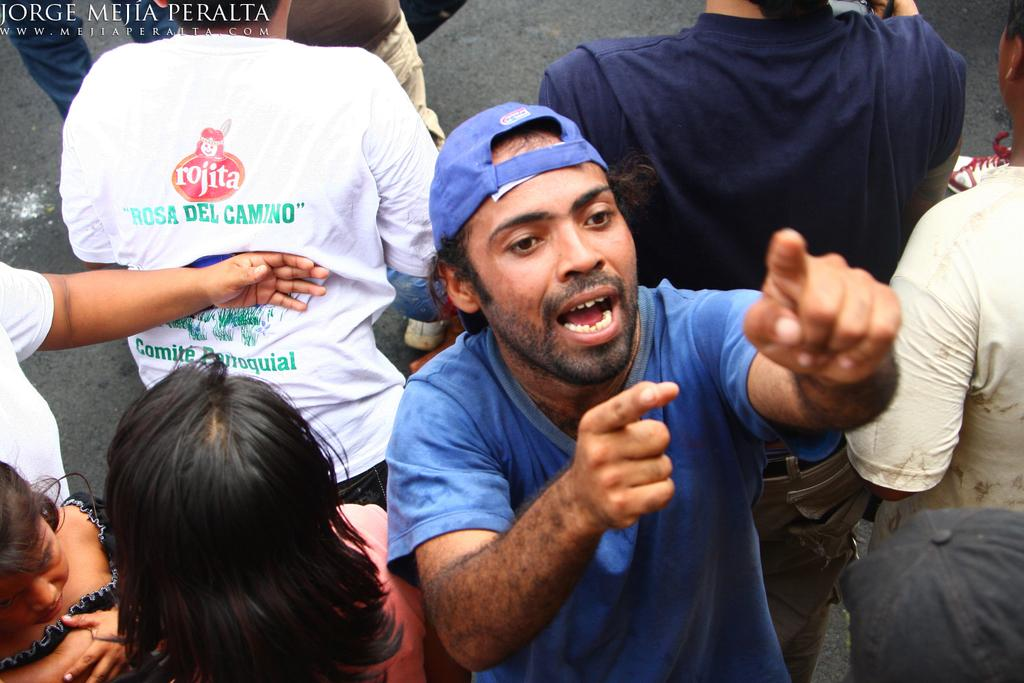What are the people in the image doing? The people in the image are standing on the road. Can you describe any specific detail about one of the people's clothing? Yes, the shirt of one person has the word "Rojita" written on it. How many rabbits can be seen in the image? There are no rabbits present in the image. What is the distance between the people and the tiger in the image? There is no tiger present in the image. 